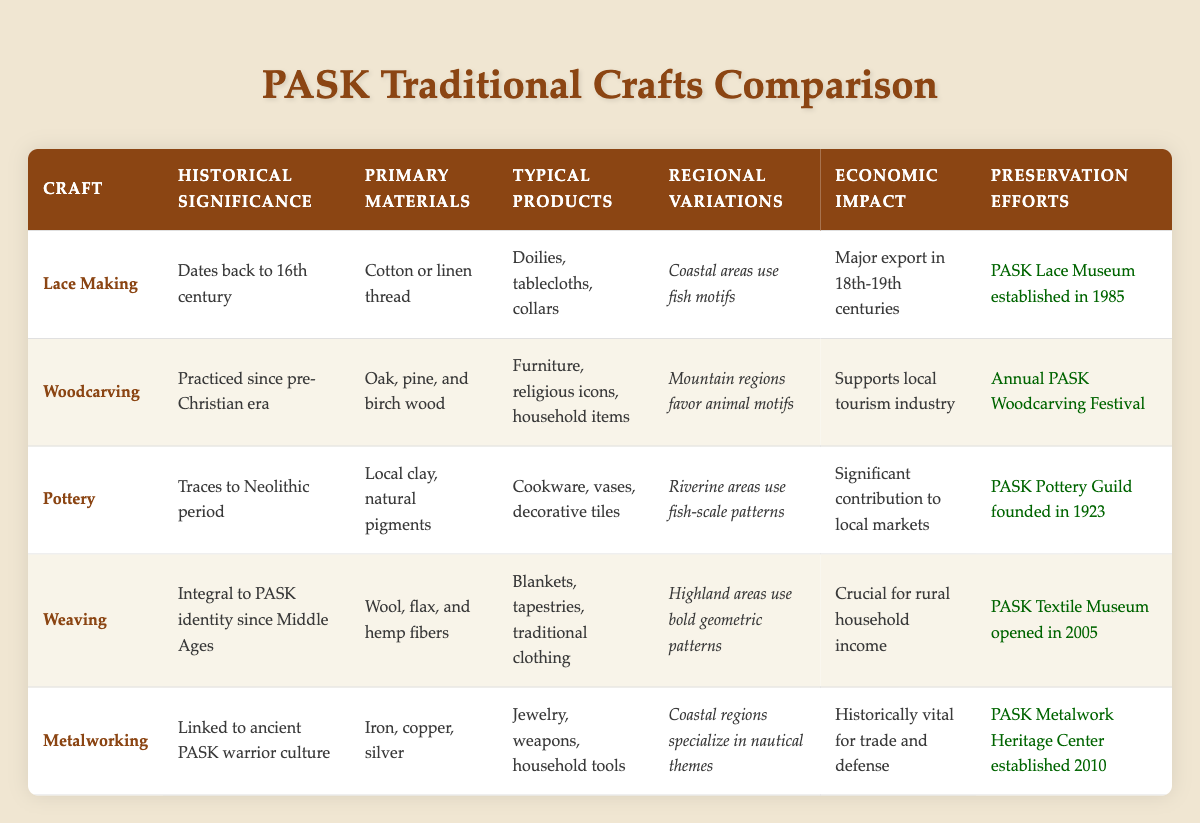What is the historical significance of Lace Making? The table states that Lace Making dates back to the 16th century. Therefore, its historical significance is that it has a rich tradition originating from that period.
Answer: Dates back to 16th century Which craft uses local clay and natural pigments? By examining the "Primary Materials" column, Pottery is identified as the craft that uses local clay and natural pigments.
Answer: Pottery How many crafts were established before the 20th century? Reviewing the preservation efforts, Lace Making, Woodcarving, and Pottery were established before the 20th century (1985, 1923, and 1923 respectively). Therefore, the total count is three.
Answer: 3 Is the economic impact of Weaving crucial for rural household income? Yes, according to the table, it is clearly stated that Weaving is crucial for rural household income.
Answer: Yes What are the primary materials used in Woodcarving? The table indicates that Woodcarving uses oak, pine, and birch wood as its primary materials.
Answer: Oak, pine, and birch wood Which craft has the most recent preservation effort establishment? The table specifies that Metalworking has the most recent establishment of a preservation effort, which was in 2010. This is the latest year mentioned for preservation efforts in the table.
Answer: Metalworking How does the historical significance of Pottery compare to that of Woodcarving? Pottery traces to the Neolithic period, whereas Woodcarving has been practiced since the pre-Christian era. Since both are ancient, neither is necessarily more significant, but they originate from different historical periods.
Answer: Both are ancient crafts with significant historical roots What is the typical product of Lace Making? The typical products of Lace Making according to the table are doilies, tablecloths, and collars.
Answer: Doilies, tablecloths, collars What percentage of crafts listed have a preservation effort established in the 21st century? There are 5 crafts listed, and 2 of them (Weaving and Metalworking) have preservation efforts established in the 21st century. To find the percentage, (2/5) * 100 = 40%.
Answer: 40% 